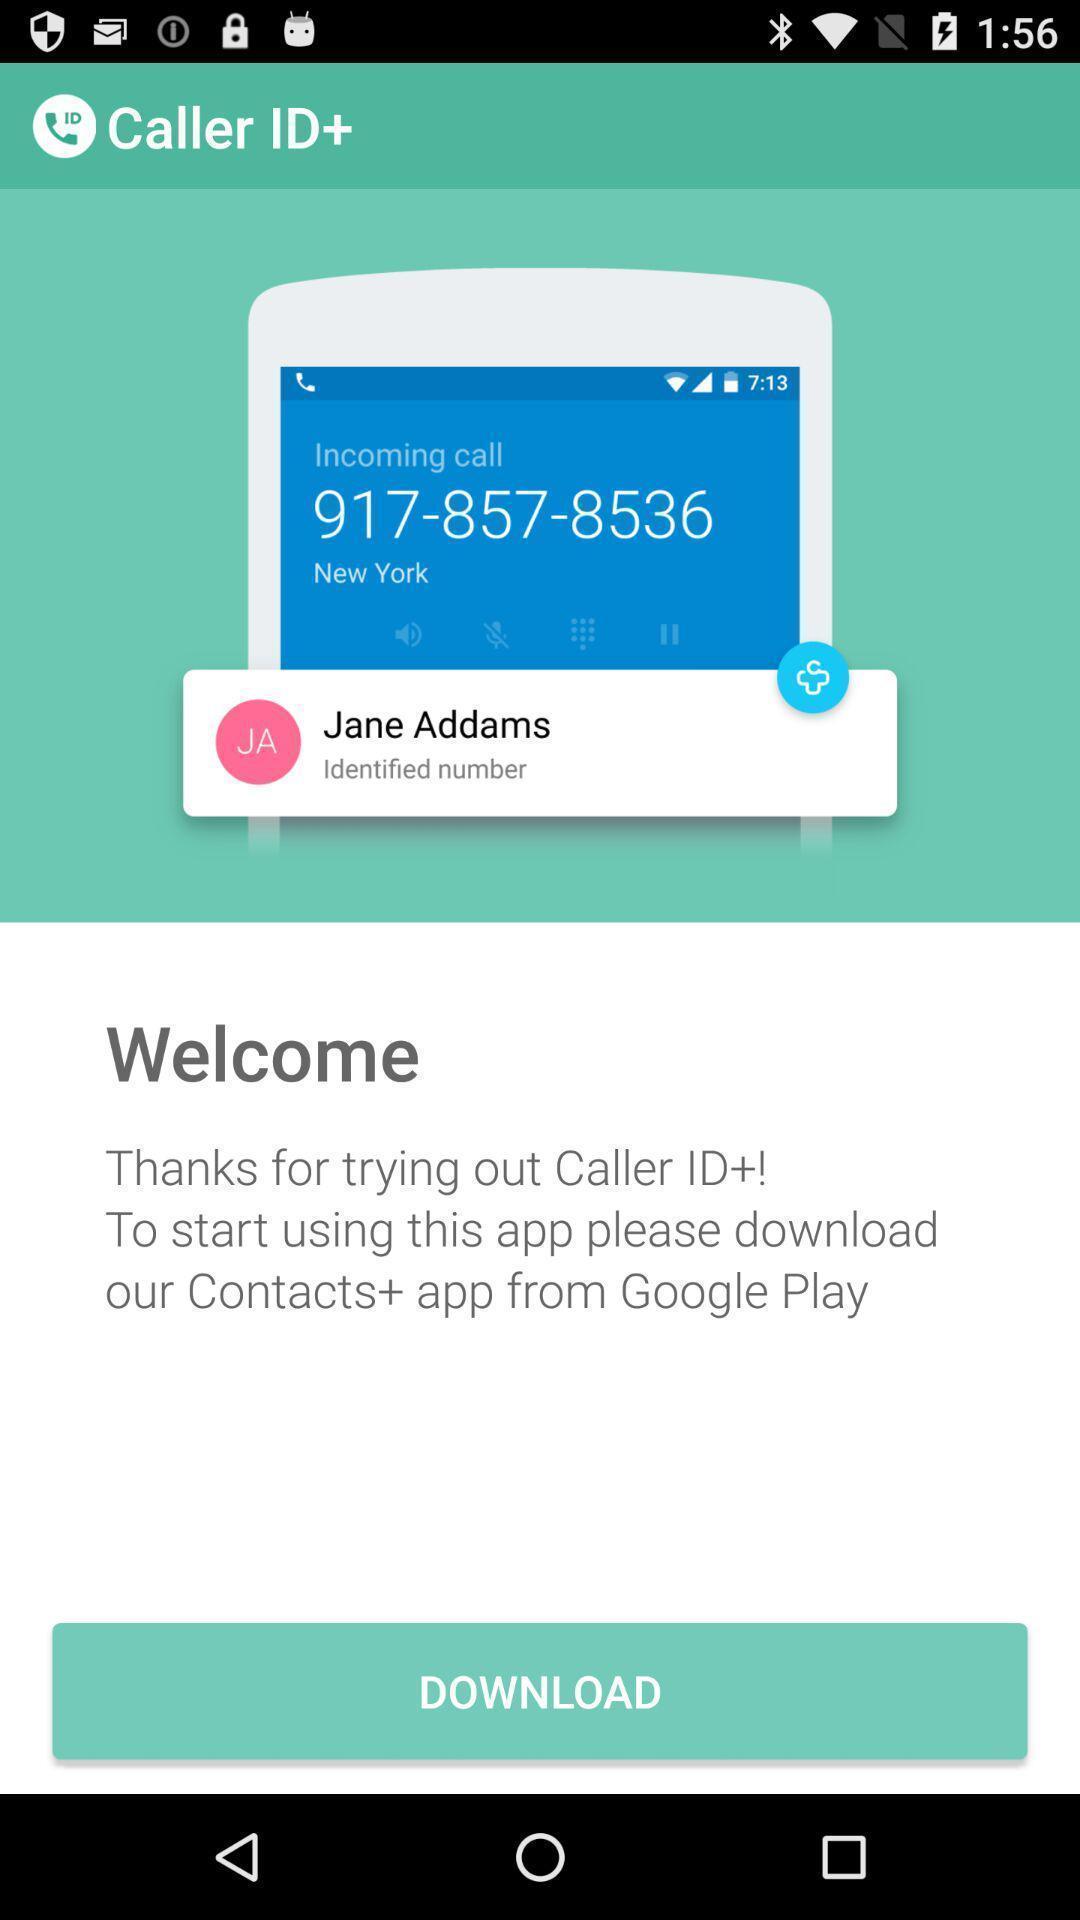What can you discern from this picture? Welcome page of calling app. 